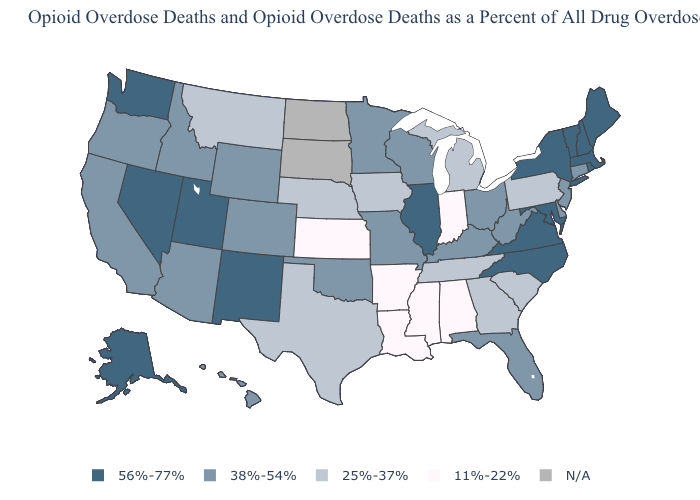What is the value of Kentucky?
Short answer required. 38%-54%. Does the map have missing data?
Quick response, please. Yes. Which states hav the highest value in the MidWest?
Quick response, please. Illinois. Does the map have missing data?
Be succinct. Yes. Which states have the highest value in the USA?
Be succinct. Alaska, Illinois, Maine, Maryland, Massachusetts, Nevada, New Hampshire, New Mexico, New York, North Carolina, Rhode Island, Utah, Vermont, Virginia, Washington. Name the states that have a value in the range N/A?
Keep it brief. North Dakota, South Dakota. Does North Carolina have the highest value in the South?
Short answer required. Yes. What is the lowest value in states that border Ohio?
Keep it brief. 11%-22%. What is the value of Iowa?
Concise answer only. 25%-37%. Name the states that have a value in the range 11%-22%?
Answer briefly. Alabama, Arkansas, Indiana, Kansas, Louisiana, Mississippi. Among the states that border Indiana , does Illinois have the highest value?
Write a very short answer. Yes. Name the states that have a value in the range 56%-77%?
Be succinct. Alaska, Illinois, Maine, Maryland, Massachusetts, Nevada, New Hampshire, New Mexico, New York, North Carolina, Rhode Island, Utah, Vermont, Virginia, Washington. What is the highest value in states that border Oklahoma?
Be succinct. 56%-77%. Which states have the highest value in the USA?
Answer briefly. Alaska, Illinois, Maine, Maryland, Massachusetts, Nevada, New Hampshire, New Mexico, New York, North Carolina, Rhode Island, Utah, Vermont, Virginia, Washington. What is the value of Texas?
Write a very short answer. 25%-37%. 